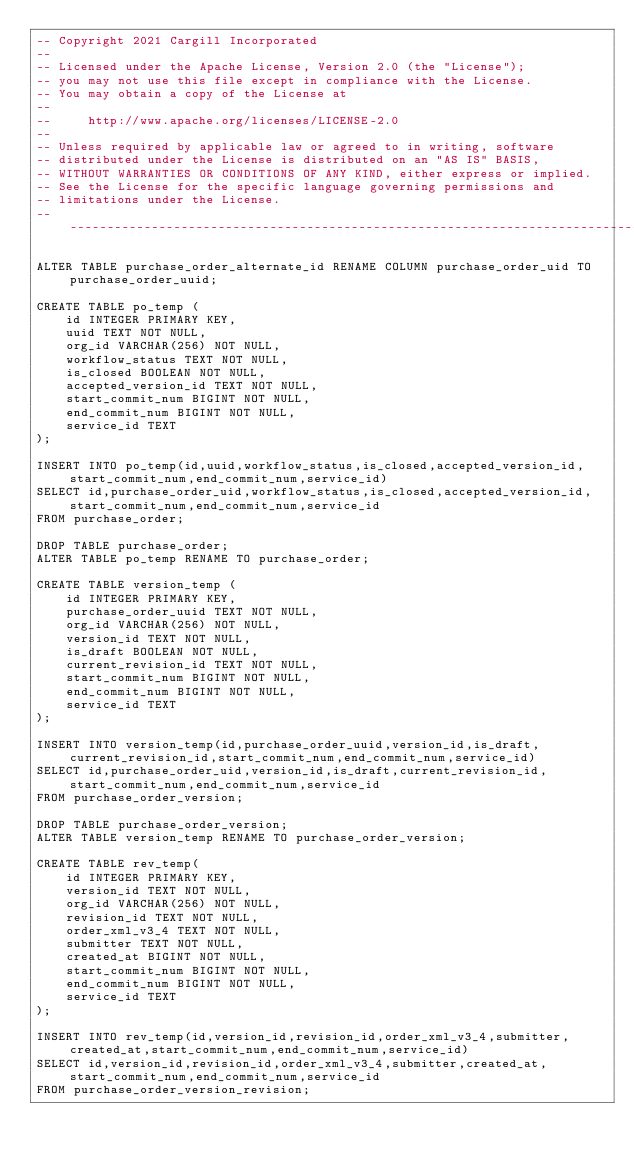Convert code to text. <code><loc_0><loc_0><loc_500><loc_500><_SQL_>-- Copyright 2021 Cargill Incorporated
--
-- Licensed under the Apache License, Version 2.0 (the "License");
-- you may not use this file except in compliance with the License.
-- You may obtain a copy of the License at
--
--     http://www.apache.org/licenses/LICENSE-2.0
--
-- Unless required by applicable law or agreed to in writing, software
-- distributed under the License is distributed on an "AS IS" BASIS,
-- WITHOUT WARRANTIES OR CONDITIONS OF ANY KIND, either express or implied.
-- See the License for the specific language governing permissions and
-- limitations under the License.
-- -----------------------------------------------------------------------------

ALTER TABLE purchase_order_alternate_id RENAME COLUMN purchase_order_uid TO purchase_order_uuid;

CREATE TABLE po_temp (
    id INTEGER PRIMARY KEY,
    uuid TEXT NOT NULL,
    org_id VARCHAR(256) NOT NULL,
    workflow_status TEXT NOT NULL,
    is_closed BOOLEAN NOT NULL,
    accepted_version_id TEXT NOT NULL,
    start_commit_num BIGINT NOT NULL,
    end_commit_num BIGINT NOT NULL,
    service_id TEXT
);

INSERT INTO po_temp(id,uuid,workflow_status,is_closed,accepted_version_id,start_commit_num,end_commit_num,service_id)
SELECT id,purchase_order_uid,workflow_status,is_closed,accepted_version_id,start_commit_num,end_commit_num,service_id
FROM purchase_order;

DROP TABLE purchase_order;
ALTER TABLE po_temp RENAME TO purchase_order;

CREATE TABLE version_temp (
    id INTEGER PRIMARY KEY,
    purchase_order_uuid TEXT NOT NULL,
    org_id VARCHAR(256) NOT NULL,
    version_id TEXT NOT NULL,
    is_draft BOOLEAN NOT NULL,
    current_revision_id TEXT NOT NULL,
    start_commit_num BIGINT NOT NULL,
    end_commit_num BIGINT NOT NULL,
    service_id TEXT
);

INSERT INTO version_temp(id,purchase_order_uuid,version_id,is_draft,current_revision_id,start_commit_num,end_commit_num,service_id)
SELECT id,purchase_order_uid,version_id,is_draft,current_revision_id,start_commit_num,end_commit_num,service_id
FROM purchase_order_version;

DROP TABLE purchase_order_version;
ALTER TABLE version_temp RENAME TO purchase_order_version;

CREATE TABLE rev_temp(
    id INTEGER PRIMARY KEY,
    version_id TEXT NOT NULL,
    org_id VARCHAR(256) NOT NULL,
    revision_id TEXT NOT NULL,
    order_xml_v3_4 TEXT NOT NULL,
    submitter TEXT NOT NULL,
    created_at BIGINT NOT NULL,
    start_commit_num BIGINT NOT NULL,
    end_commit_num BIGINT NOT NULL,
    service_id TEXT
);

INSERT INTO rev_temp(id,version_id,revision_id,order_xml_v3_4,submitter,created_at,start_commit_num,end_commit_num,service_id)
SELECT id,version_id,revision_id,order_xml_v3_4,submitter,created_at,start_commit_num,end_commit_num,service_id
FROM purchase_order_version_revision;
</code> 